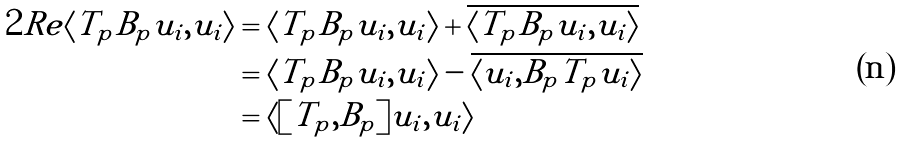<formula> <loc_0><loc_0><loc_500><loc_500>2 R e \langle T _ { p } B _ { p } u _ { i } , u _ { i } \rangle & = \langle T _ { p } B _ { p } u _ { i } , u _ { i } \rangle + \overline { \langle T _ { p } B _ { p } u _ { i } , u _ { i } \rangle } \\ & = \langle T _ { p } B _ { p } u _ { i } , u _ { i } \rangle - \overline { \langle u _ { i } , B _ { p } T _ { p } u _ { i } \rangle } \\ & = \langle [ T _ { p } , B _ { p } ] u _ { i } , u _ { i } \rangle</formula> 